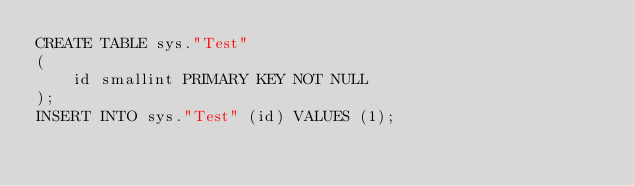<code> <loc_0><loc_0><loc_500><loc_500><_SQL_>CREATE TABLE sys."Test"
(
    id smallint PRIMARY KEY NOT NULL
);
INSERT INTO sys."Test" (id) VALUES (1);</code> 